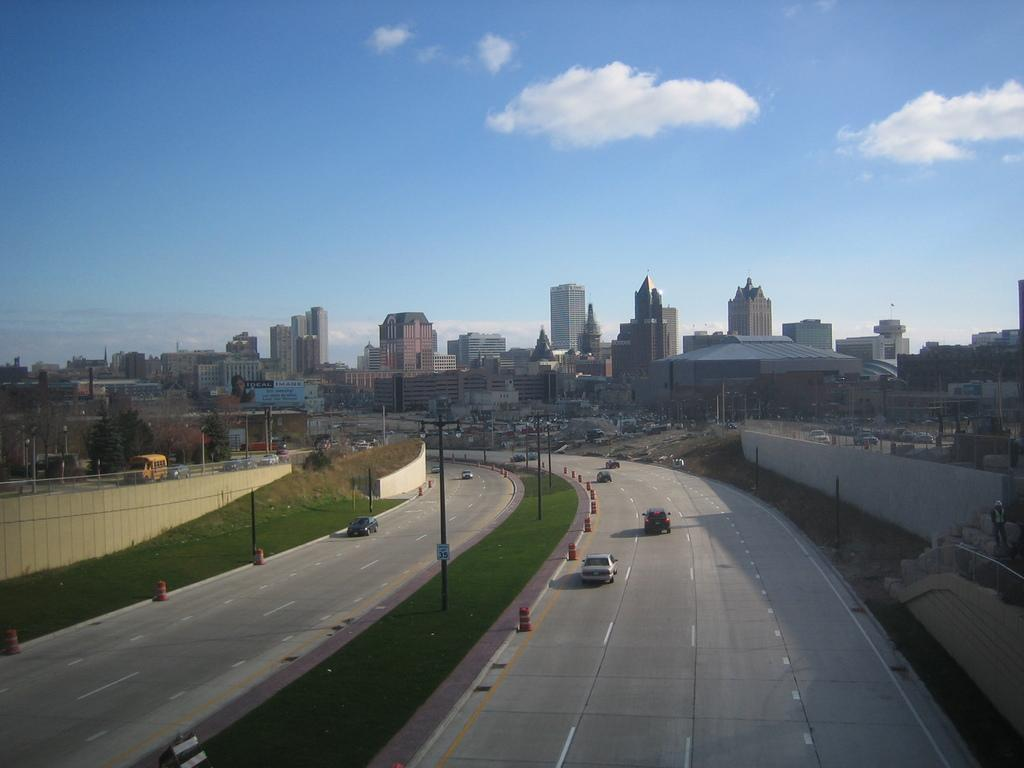What type of view is shown in the image? The image is an aerial view. What can be seen on the ground in the image? There are roads, vehicles, and buildings visible in the image. What helps to illuminate the roads at night? Street lights are present in the image to illuminate the roads. Are there any lights visible in the image? Yes, lights are visible in the image, including street lights and lights from buildings. How many stitches are required to sew the trip in the image? There is no trip or stitching present in the image; it is an aerial view of a cityscape with roads, vehicles, and buildings. 